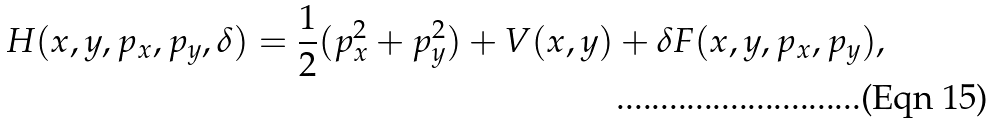Convert formula to latex. <formula><loc_0><loc_0><loc_500><loc_500>H ( x , y , p _ { x } , p _ { y } , \delta ) = \frac { 1 } { 2 } ( p _ { x } ^ { 2 } + p _ { y } ^ { 2 } ) + V ( x , y ) + \delta F ( x , y , p _ { x } , p _ { y } ) ,</formula> 